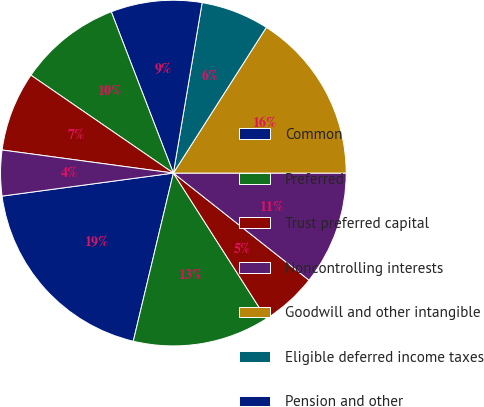Convert chart. <chart><loc_0><loc_0><loc_500><loc_500><pie_chart><fcel>Common<fcel>Preferred<fcel>Trust preferred capital<fcel>Noncontrolling interests<fcel>Goodwill and other intangible<fcel>Eligible deferred income taxes<fcel>Pension and other<fcel>Net unrealized securities<fcel>Net unrealized (gains)/losses<fcel>Other<nl><fcel>19.15%<fcel>12.77%<fcel>5.32%<fcel>10.64%<fcel>15.96%<fcel>6.38%<fcel>8.51%<fcel>9.57%<fcel>7.45%<fcel>4.26%<nl></chart> 